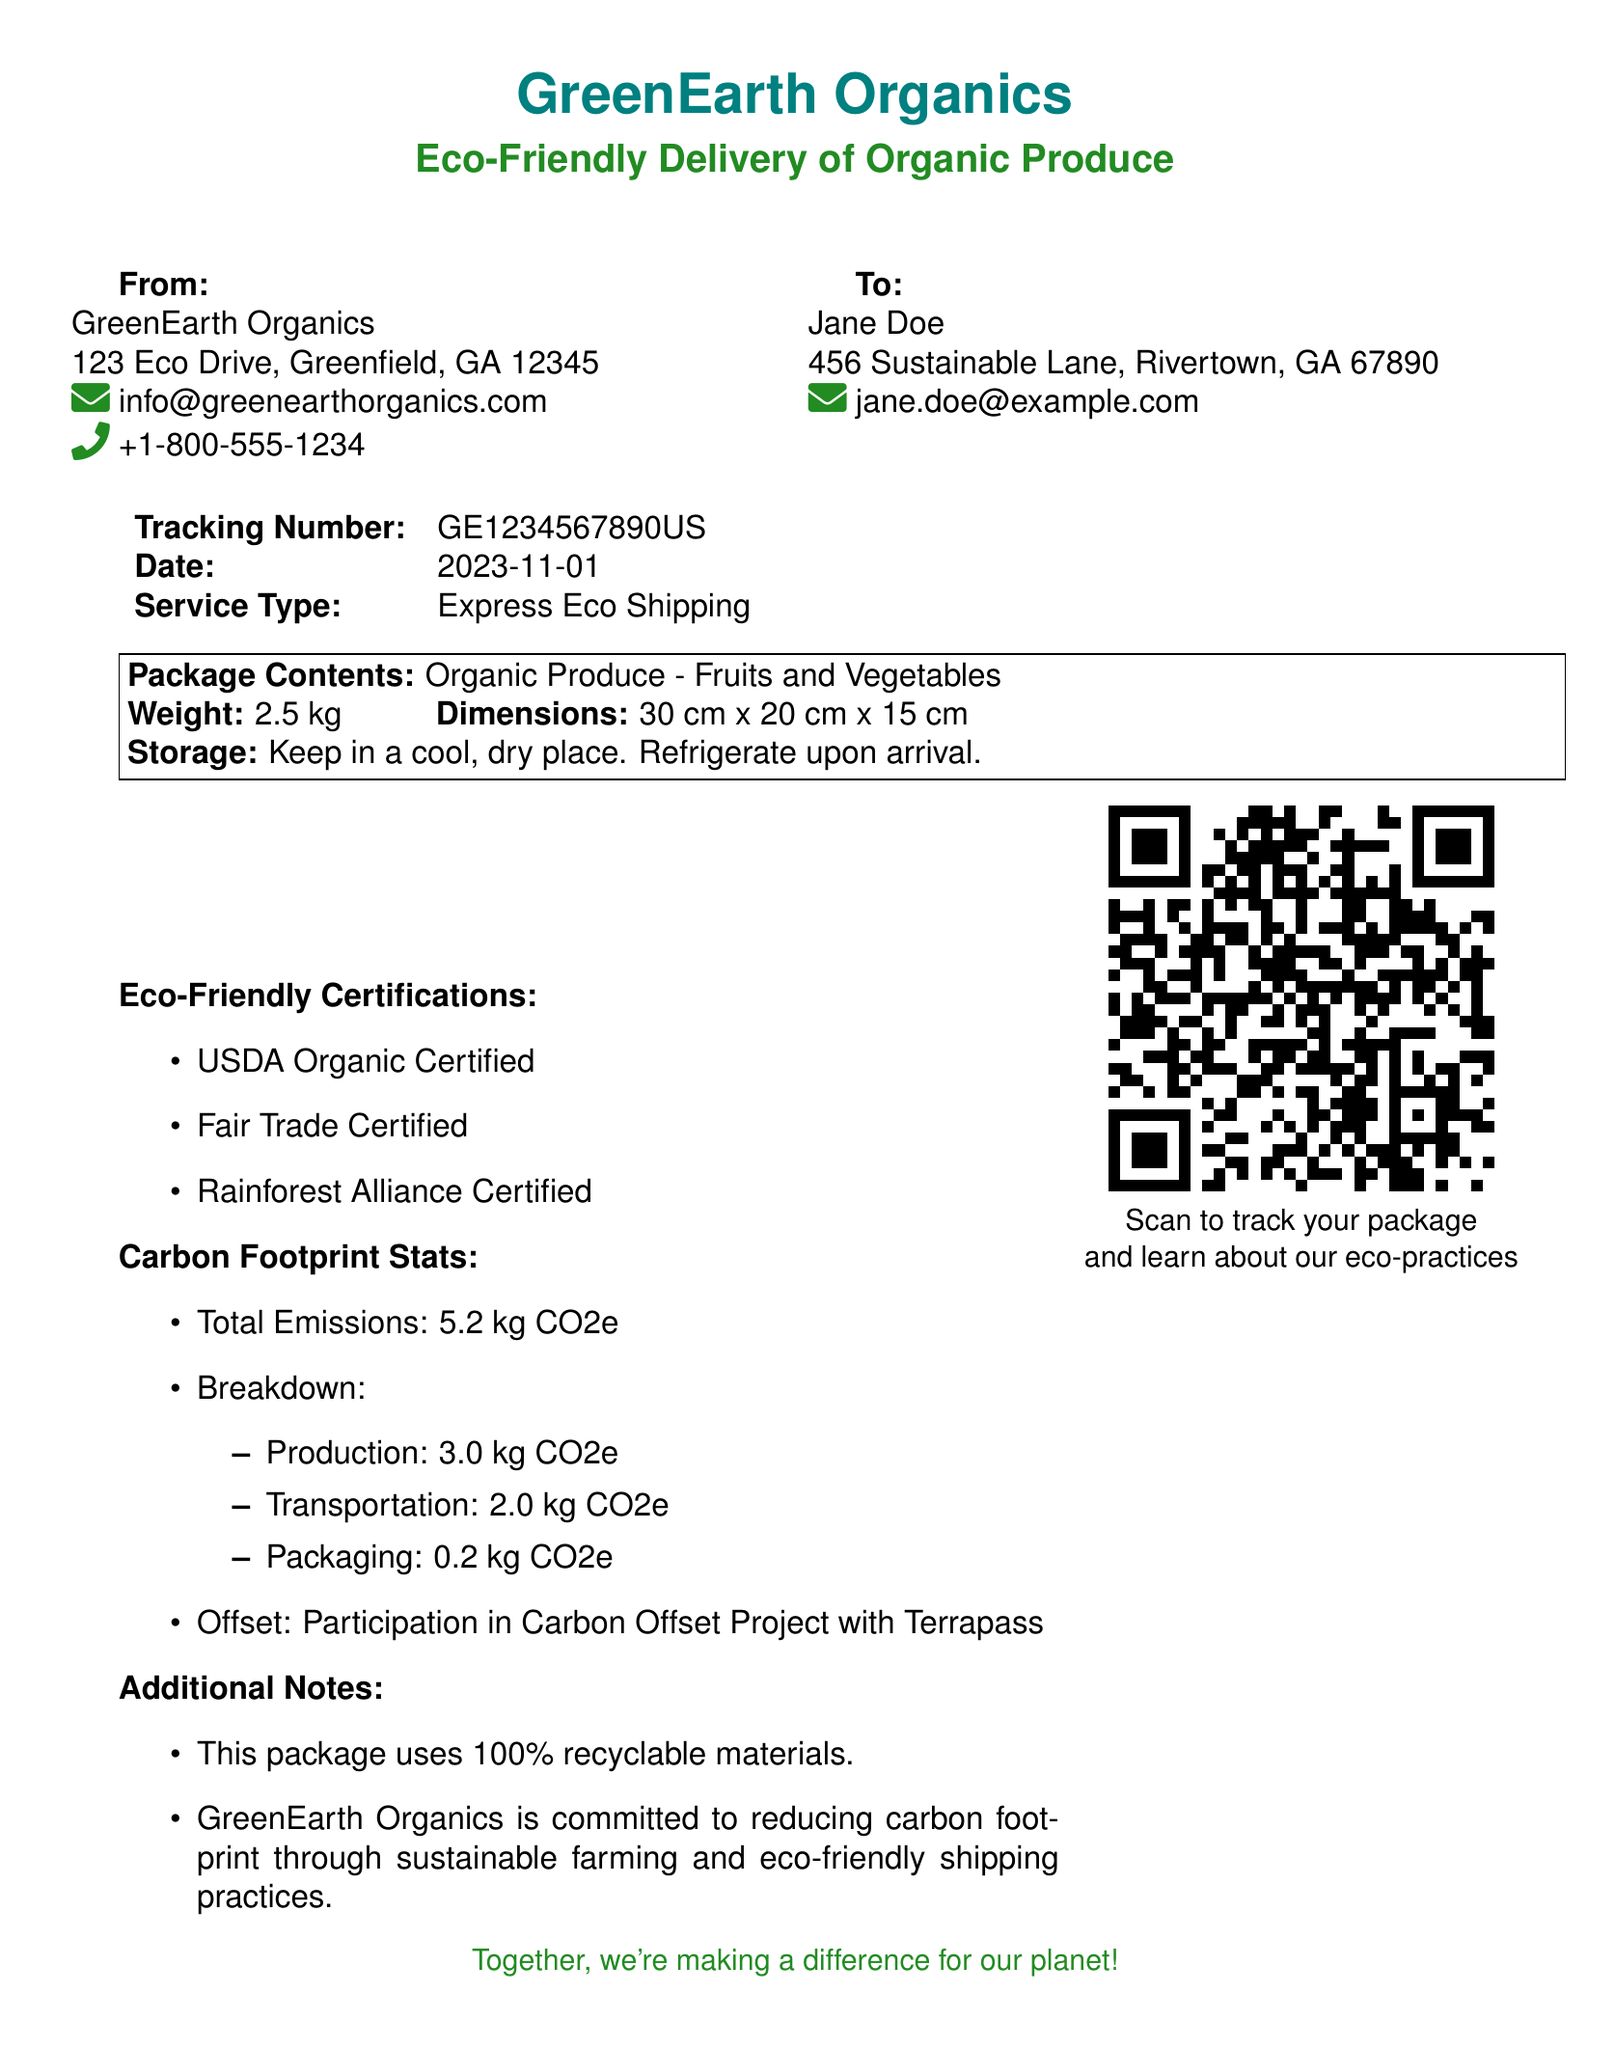what is the company name? The company name is stated at the top of the document as "GreenEarth Organics."
Answer: GreenEarth Organics what is the tracking number? The tracking number is provided in the details section of the document, which is "GE1234567890US."
Answer: GE1234567890US what is the total emissions? The total emissions are mentioned under the Carbon Footprint Stats section as "5.2 kg CO2e."
Answer: 5.2 kg CO2e what is the production carbon footprint? The document lists the production emissions under the Carbon Footprint Stats as "3.0 kg CO2e."
Answer: 3.0 kg CO2e what is the weight of the package? The weight of the package is listed in the package contents section as "2.5 kg."
Answer: 2.5 kg what type of delivery service is used? The service type is indicated in the document as "Express Eco Shipping."
Answer: Express Eco Shipping who is the recipient? The recipient's name is mentioned in the document as "Jane Doe."
Answer: Jane Doe how many eco-friendly certifications are listed? The document enumerates three eco-friendly certifications under the Eco-Friendly Certifications section.
Answer: 3 what materials are used for packaging? The additional notes section states that the package uses "100% recyclable materials."
Answer: 100% recyclable materials 